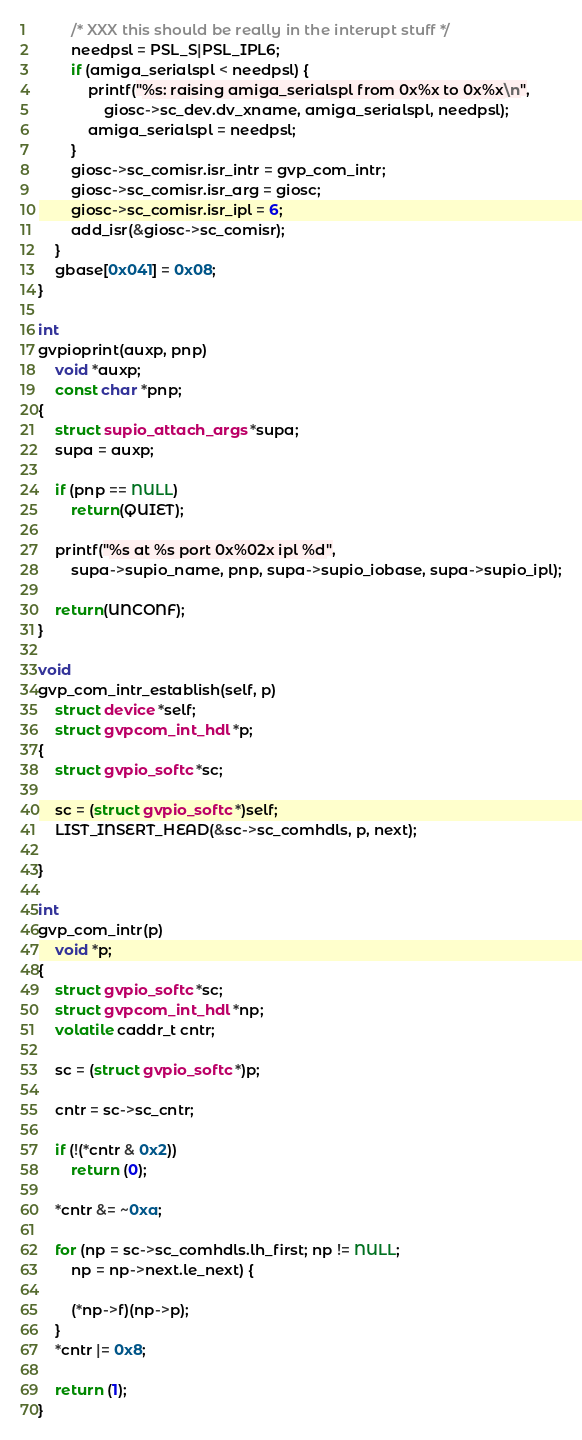<code> <loc_0><loc_0><loc_500><loc_500><_C_>		/* XXX this should be really in the interupt stuff */
		needpsl = PSL_S|PSL_IPL6;
		if (amiga_serialspl < needpsl) {
			printf("%s: raising amiga_serialspl from 0x%x to 0x%x\n",
			    giosc->sc_dev.dv_xname, amiga_serialspl, needpsl);
			amiga_serialspl = needpsl;
		}
		giosc->sc_comisr.isr_intr = gvp_com_intr;
		giosc->sc_comisr.isr_arg = giosc;
		giosc->sc_comisr.isr_ipl = 6;
		add_isr(&giosc->sc_comisr);
	}
	gbase[0x041] = 0x08;
}

int
gvpioprint(auxp, pnp)
	void *auxp;
	const char *pnp;
{
	struct supio_attach_args *supa;
	supa = auxp;

	if (pnp == NULL)
		return(QUIET);

	printf("%s at %s port 0x%02x ipl %d",
	    supa->supio_name, pnp, supa->supio_iobase, supa->supio_ipl);

	return(UNCONF);
}

void
gvp_com_intr_establish(self, p)
	struct device *self;
	struct gvpcom_int_hdl *p;
{
	struct gvpio_softc *sc;

	sc = (struct gvpio_softc *)self;
	LIST_INSERT_HEAD(&sc->sc_comhdls, p, next);

}

int
gvp_com_intr(p)
	void *p;
{
	struct gvpio_softc *sc;
	struct gvpcom_int_hdl *np;
	volatile caddr_t cntr;

	sc = (struct gvpio_softc *)p;

	cntr = sc->sc_cntr;

	if (!(*cntr & 0x2))
		return (0);

	*cntr &= ~0xa;

	for (np = sc->sc_comhdls.lh_first; np != NULL;
	    np = np->next.le_next) {

		(*np->f)(np->p);
	}
	*cntr |= 0x8;

	return (1);
}
</code> 